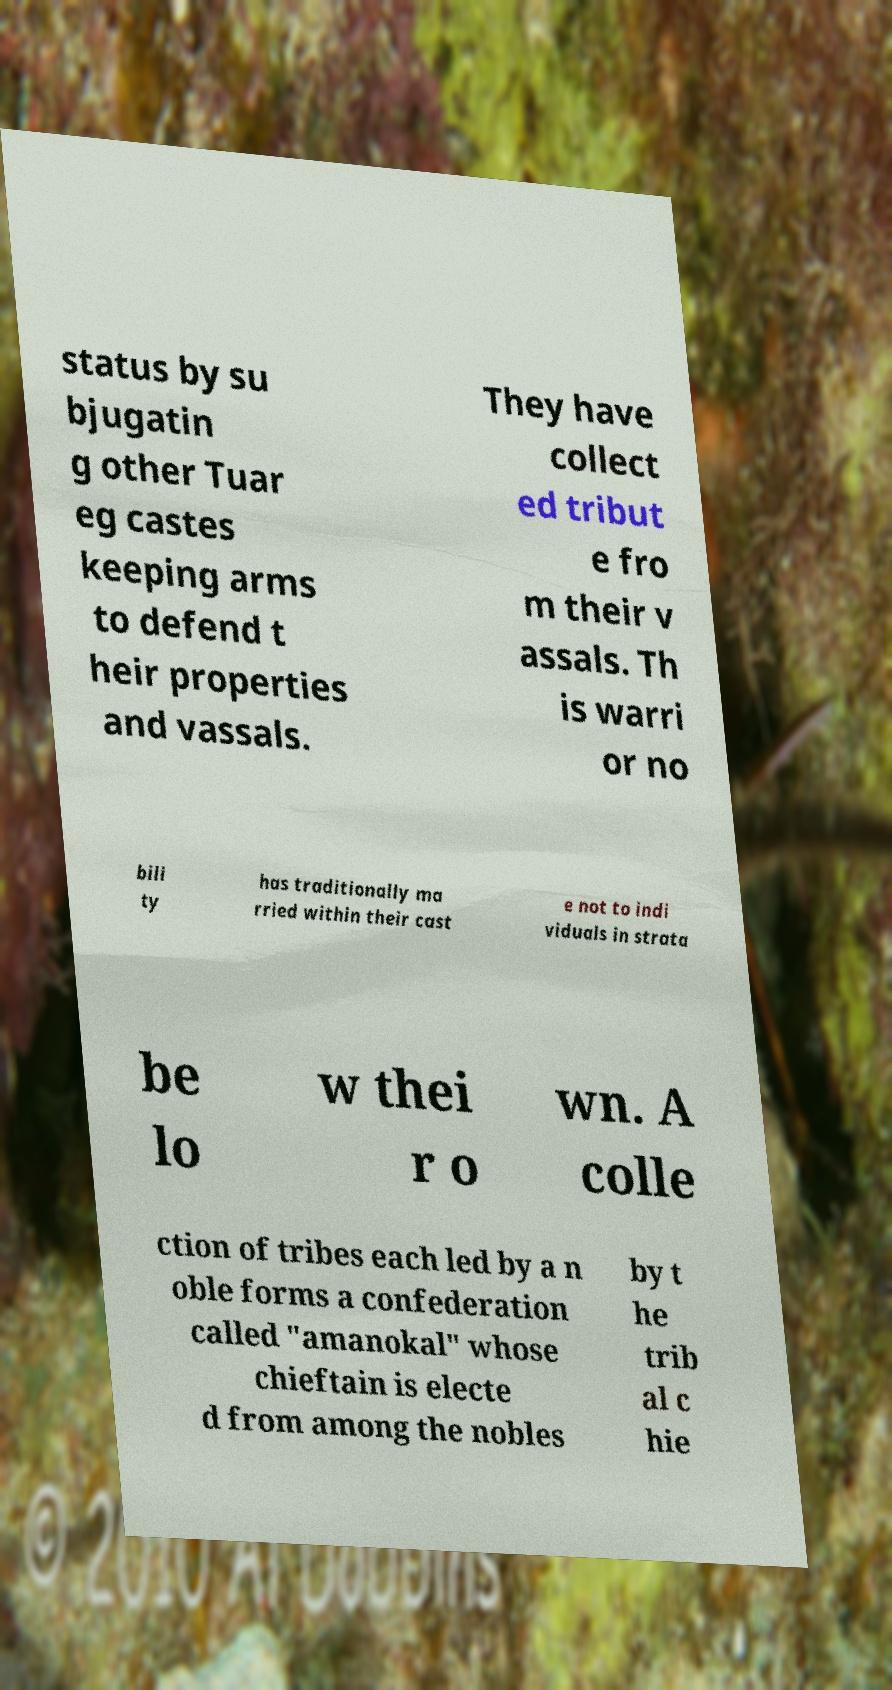Can you read and provide the text displayed in the image?This photo seems to have some interesting text. Can you extract and type it out for me? status by su bjugatin g other Tuar eg castes keeping arms to defend t heir properties and vassals. They have collect ed tribut e fro m their v assals. Th is warri or no bili ty has traditionally ma rried within their cast e not to indi viduals in strata be lo w thei r o wn. A colle ction of tribes each led by a n oble forms a confederation called "amanokal" whose chieftain is electe d from among the nobles by t he trib al c hie 